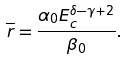<formula> <loc_0><loc_0><loc_500><loc_500>\overline { r } = \frac { \alpha _ { 0 } E _ { c } ^ { \delta - \gamma + 2 } } { \beta _ { 0 } } .</formula> 